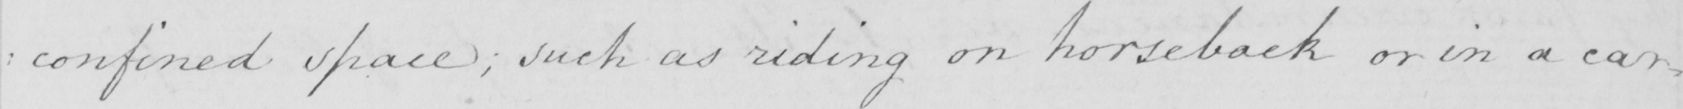What text is written in this handwritten line? : confined space ; such as riding on horseback or in a car= 